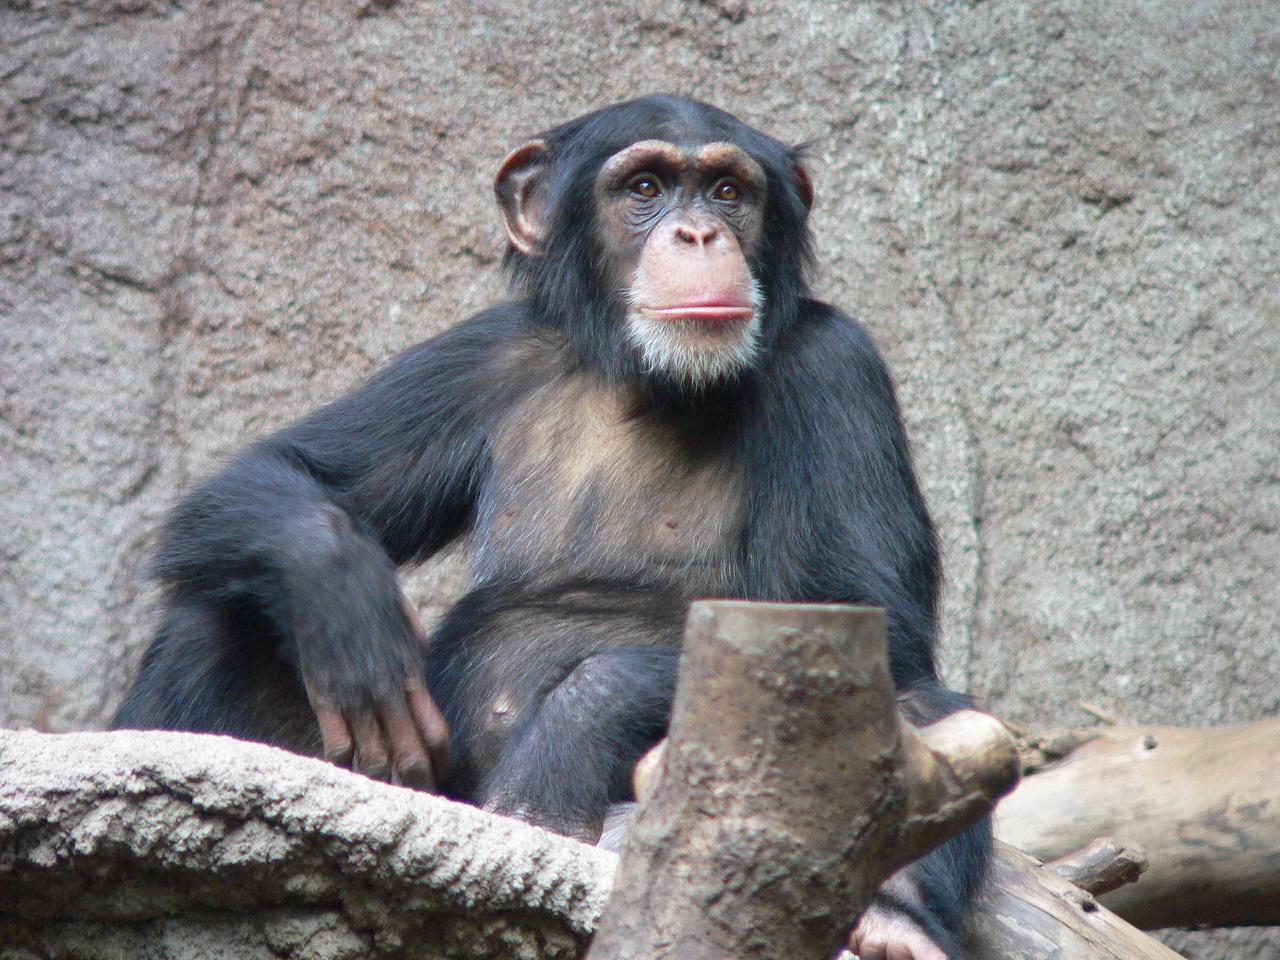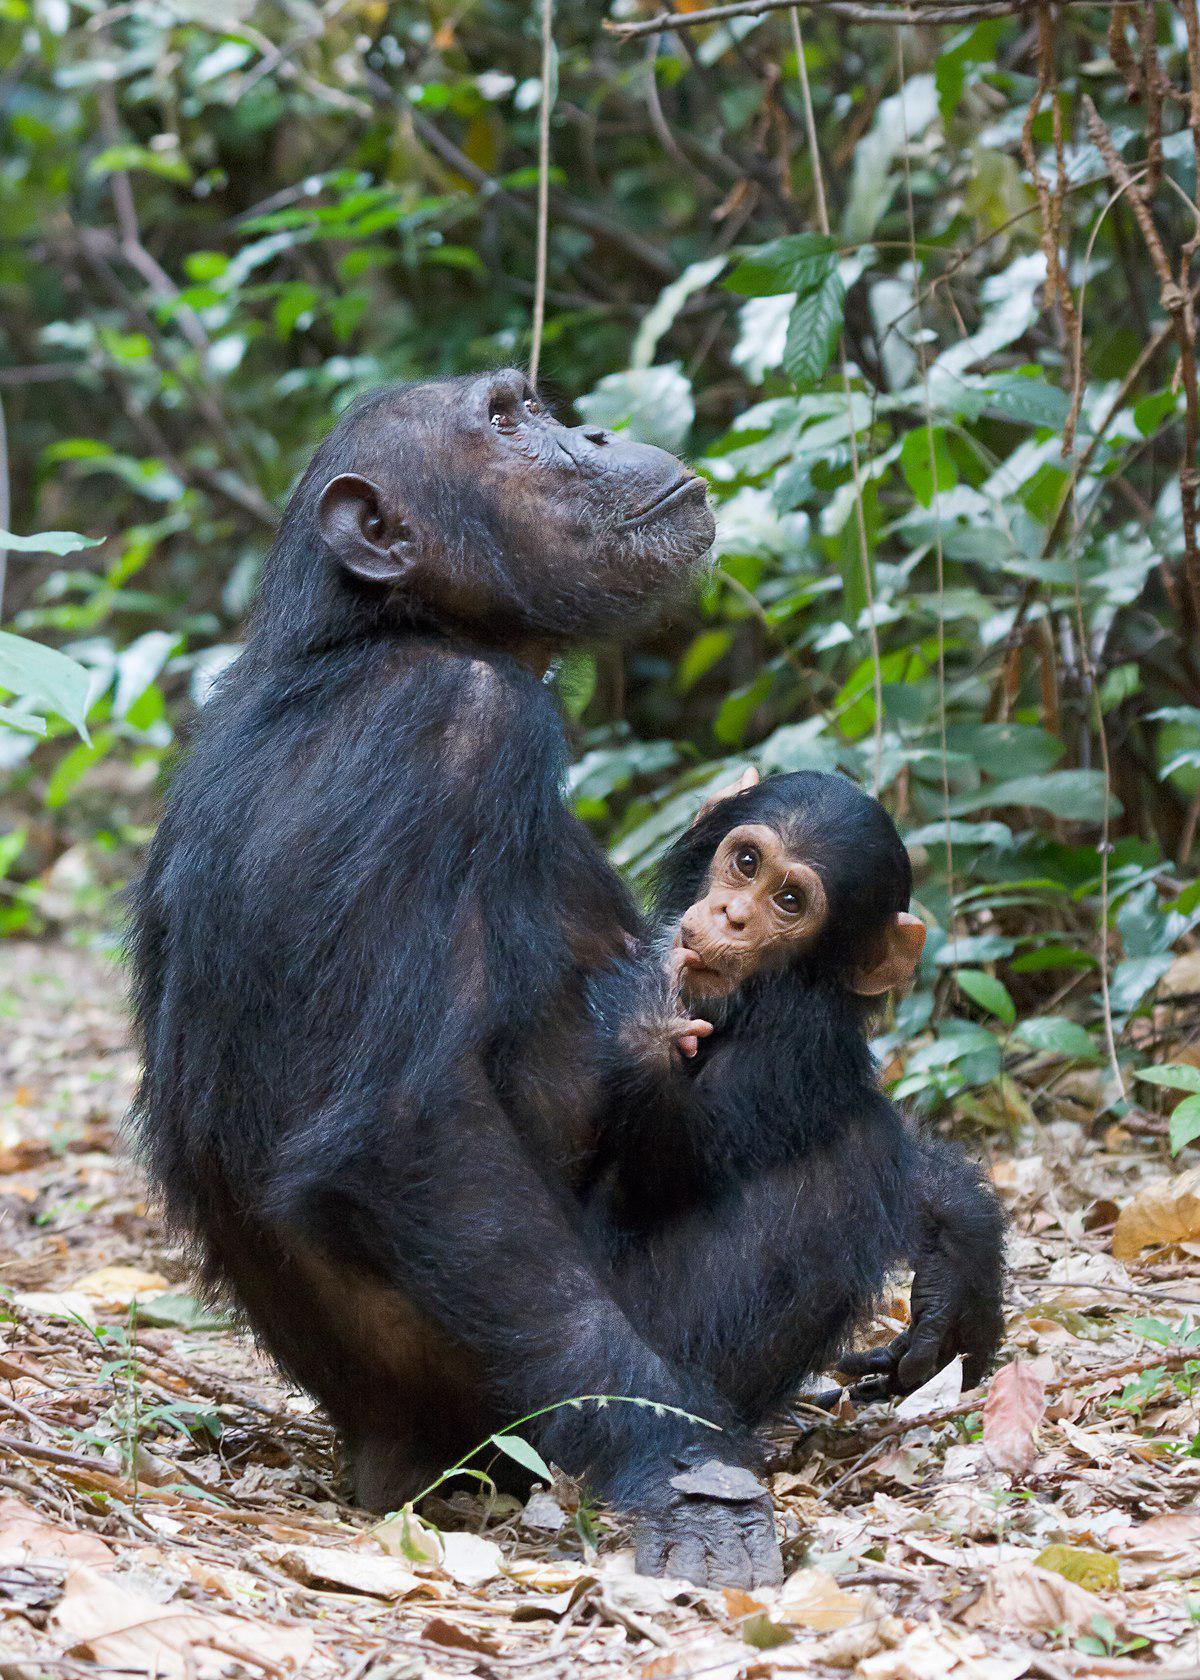The first image is the image on the left, the second image is the image on the right. Examine the images to the left and right. Is the description "There is a single hairless chimp in the right image." accurate? Answer yes or no. No. The first image is the image on the left, the second image is the image on the right. For the images shown, is this caption "An image shows one squatting ape, which is hairless." true? Answer yes or no. No. 